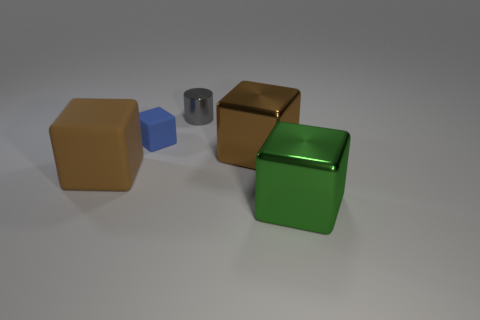Subtract all cyan balls. How many brown blocks are left? 2 Subtract 2 cubes. How many cubes are left? 2 Subtract all large blocks. How many blocks are left? 1 Subtract all blue blocks. How many blocks are left? 3 Subtract all cubes. How many objects are left? 1 Add 2 large green blocks. How many objects exist? 7 Subtract all cyan cubes. Subtract all cyan cylinders. How many cubes are left? 4 Subtract 0 brown spheres. How many objects are left? 5 Subtract all big green cylinders. Subtract all small matte blocks. How many objects are left? 4 Add 2 large green blocks. How many large green blocks are left? 3 